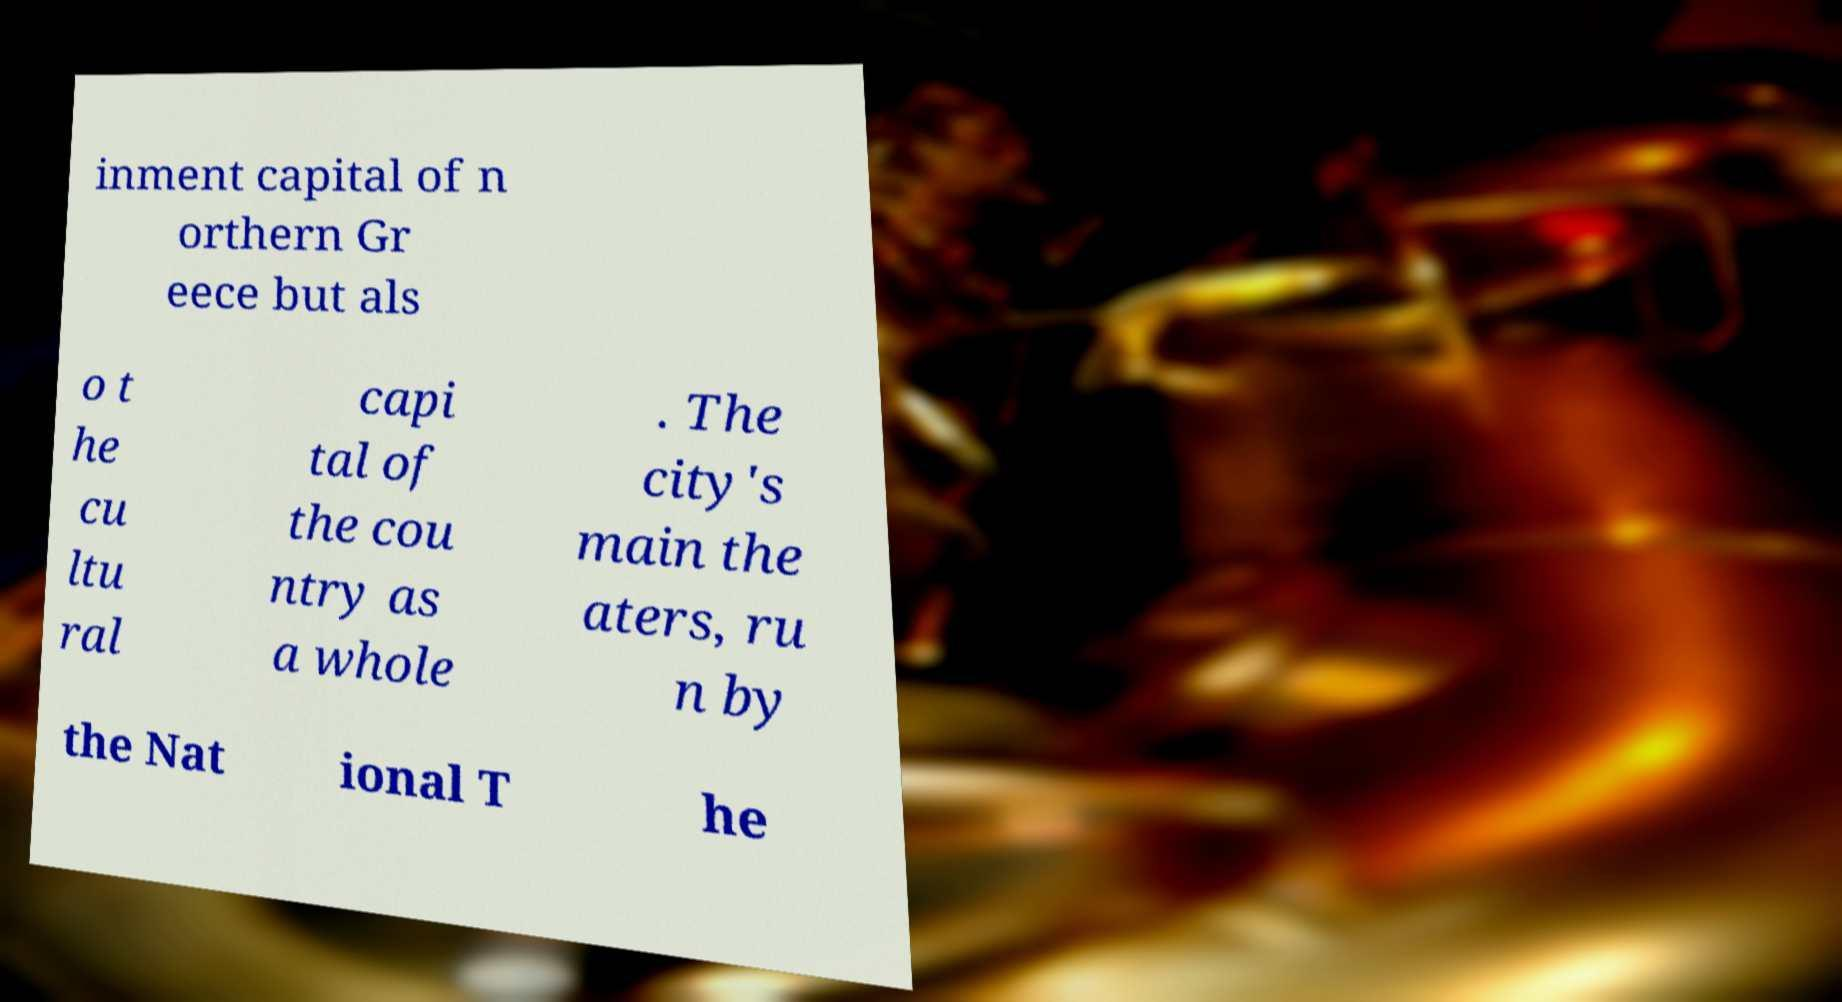Please read and relay the text visible in this image. What does it say? inment capital of n orthern Gr eece but als o t he cu ltu ral capi tal of the cou ntry as a whole . The city's main the aters, ru n by the Nat ional T he 